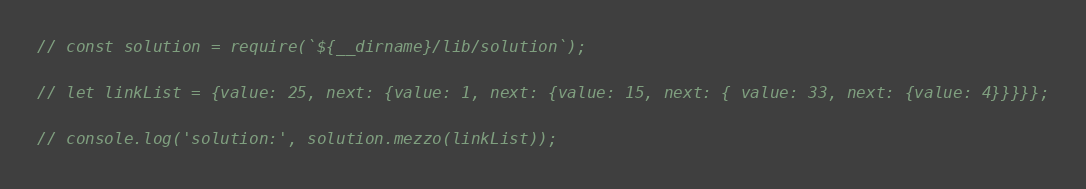<code> <loc_0><loc_0><loc_500><loc_500><_JavaScript_>// const solution = require(`${__dirname}/lib/solution`);

// let linkList = {value: 25, next: {value: 1, next: {value: 15, next: { value: 33, next: {value: 4}}}}};

// console.log('solution:', solution.mezzo(linkList));</code> 